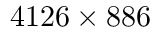Convert formula to latex. <formula><loc_0><loc_0><loc_500><loc_500>4 1 2 6 \times 8 8 6</formula> 